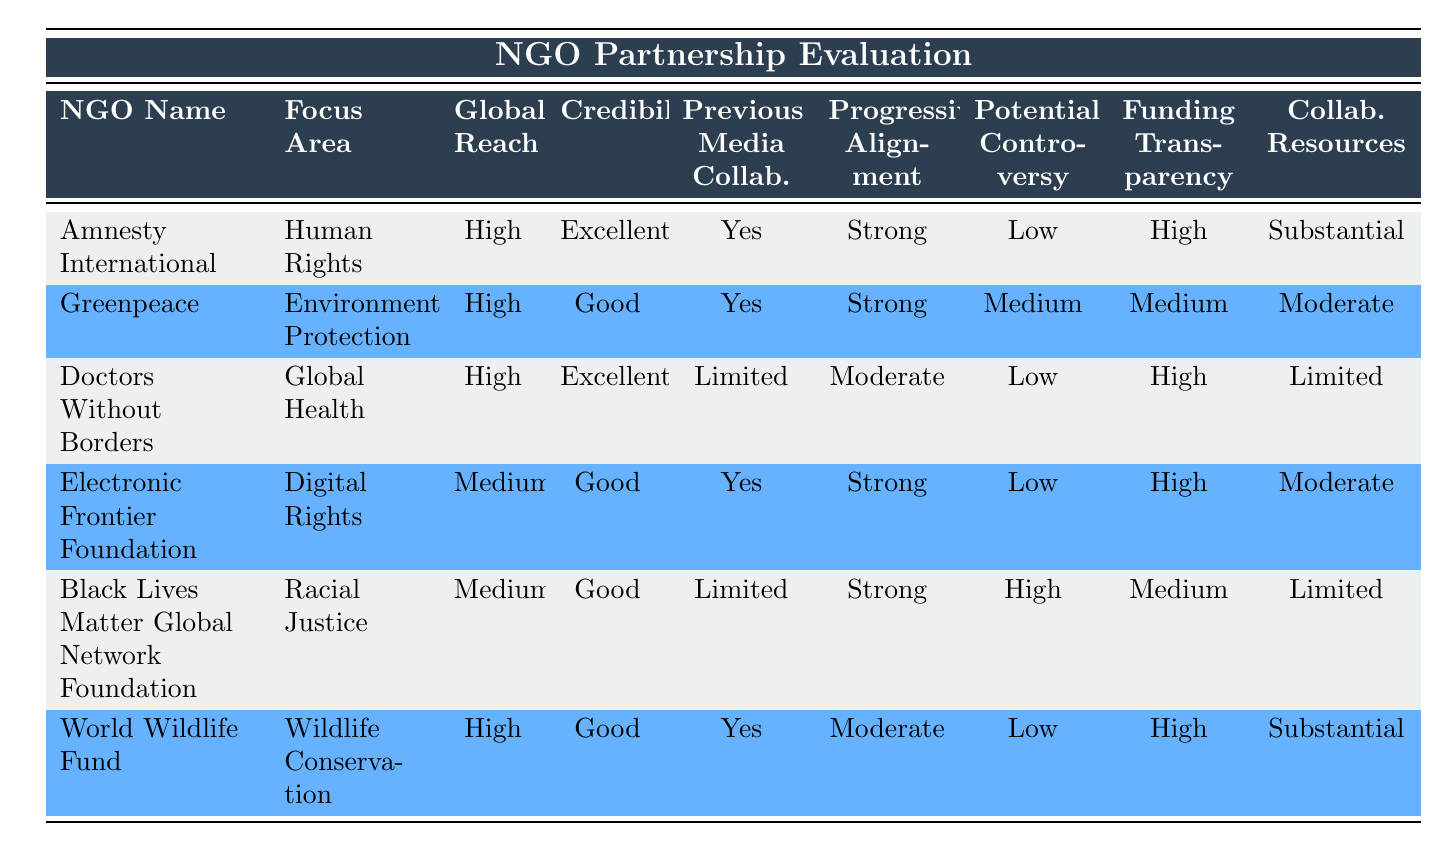What is the focus area of Amnesty International? The table indicates that Amnesty International's focus area is Human Rights, as specified in the "Focus Area" column corresponding to the row for this NGO.
Answer: Human Rights Which NGO has a strong alignment with progressive values but limited previous media collaborations? Looking through the "Alignment with Progressive Values" and "Previous Media Collaborations" columns, the Black Lives Matter Global Network Foundation shows strong alignment with progressive values and limited media collaborations.
Answer: Black Lives Matter Global Network Foundation What is the funding transparency rating for Greenpeace? By checking the "Funding Transparency" column for Greenpeace, we see that its rating is Medium.
Answer: Medium Which NGOs have a high global reach? From the "Global Reach" column, we can find three NGOs listed: Amnesty International, Greenpeace, and World Wildlife Fund all have a high global reach.
Answer: Amnesty International, Greenpeace, World Wildlife Fund How many NGOs have both excellent credibility and high funding transparency? We need to look at the "Credibility" and "Funding Transparency" columns. Only Amnesty International and Doctors Without Borders have excellent credibility and high funding transparency. Thus, the count is two.
Answer: 2 Which NGO focuses on digital rights and what is its potential controversy level? The Electronic Frontier Foundation focuses on Digital Rights, and according to the "Potential Controversy" column, it has a low level of potential controversy.
Answer: Low What is the average rating for funding transparency among the NGOs listed? The funding transparency ratings are as follows: High (3 times), Medium (2 times). The average can be calculated as follows: (High + High + High + Medium + Medium) / 6. Assigning values: High = 1, Medium = 0.5; therefore, (3 + 1) / 6 = 0.67, translating to High.
Answer: High Is it true that all NGOs listed have previous media collaborations? Reviewing the "Previous Media Collaborations" column, we see that while most NGOs have collaborations, Doctors Without Borders and Black Lives Matter Global Network Foundation have limited collaborations. Thus, the statement is false.
Answer: No Which NGO has a substantial amount of available resources for collaboration and low potential controversy? Both Amnesty International and World Wildlife Fund have substantial resources for collaboration and low potential controversy, as seen in the corresponding columns.
Answer: Amnesty International, World Wildlife Fund 